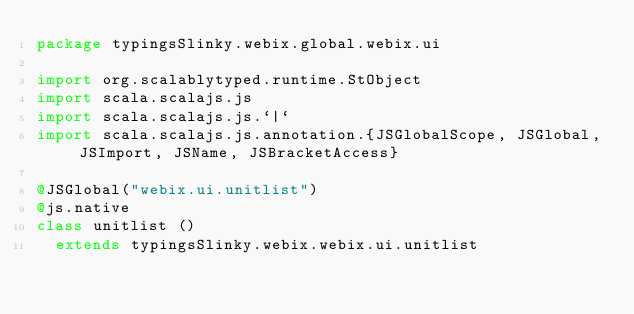<code> <loc_0><loc_0><loc_500><loc_500><_Scala_>package typingsSlinky.webix.global.webix.ui

import org.scalablytyped.runtime.StObject
import scala.scalajs.js
import scala.scalajs.js.`|`
import scala.scalajs.js.annotation.{JSGlobalScope, JSGlobal, JSImport, JSName, JSBracketAccess}

@JSGlobal("webix.ui.unitlist")
@js.native
class unitlist ()
  extends typingsSlinky.webix.webix.ui.unitlist
</code> 